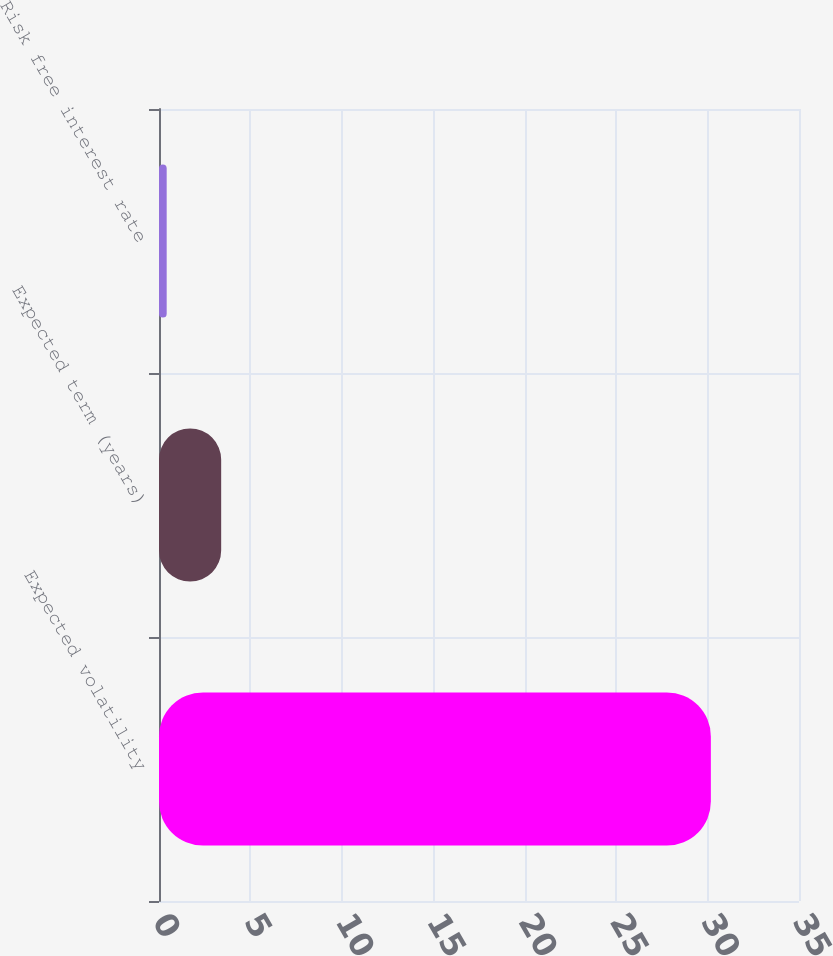Convert chart to OTSL. <chart><loc_0><loc_0><loc_500><loc_500><bar_chart><fcel>Expected volatility<fcel>Expected term (years)<fcel>Risk free interest rate<nl><fcel>30.18<fcel>3.4<fcel>0.42<nl></chart> 